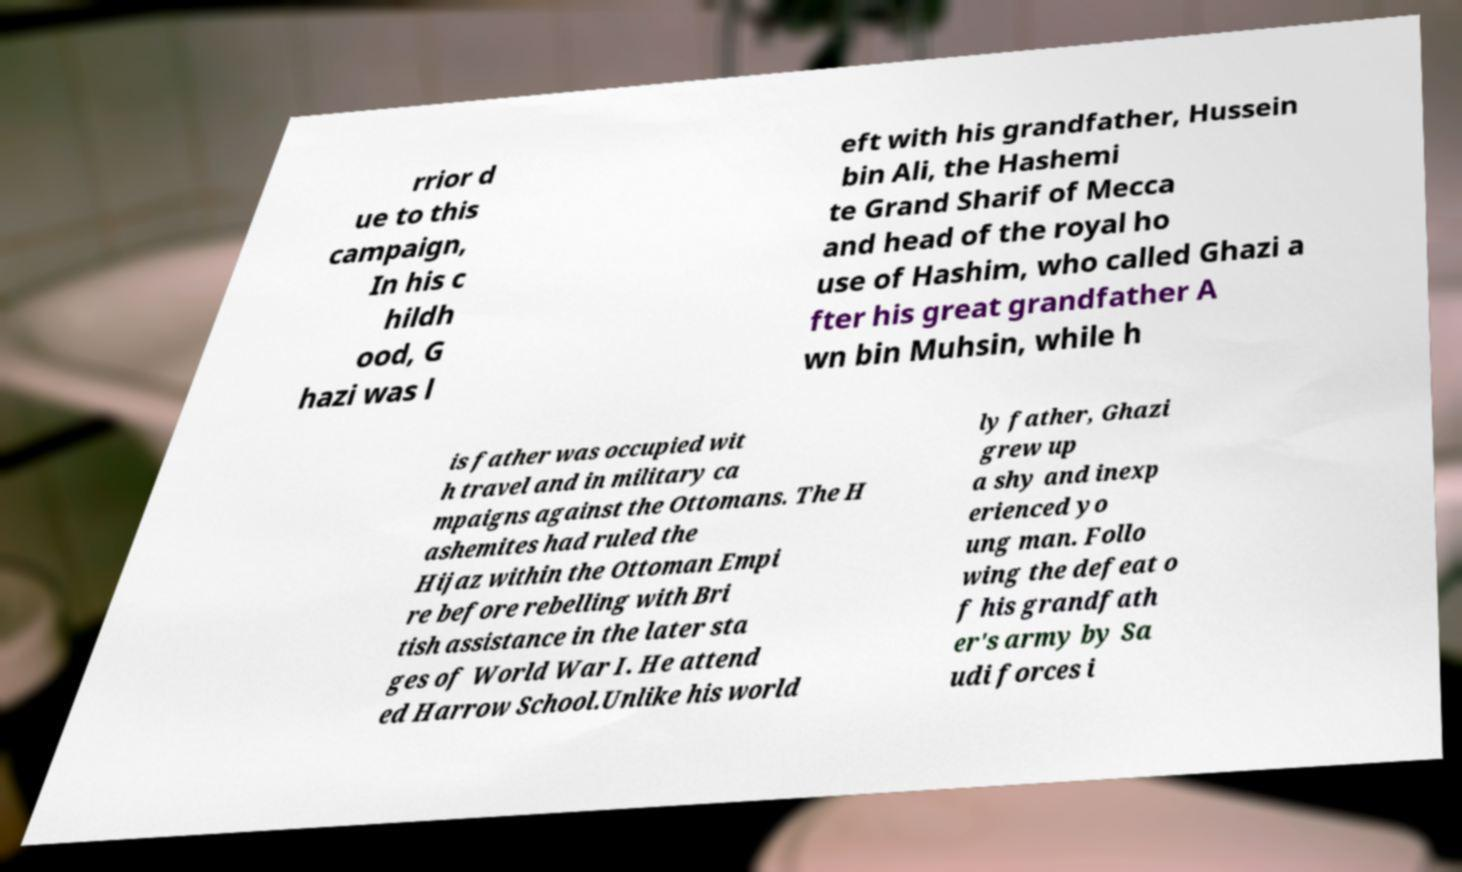There's text embedded in this image that I need extracted. Can you transcribe it verbatim? rrior d ue to this campaign, In his c hildh ood, G hazi was l eft with his grandfather, Hussein bin Ali, the Hashemi te Grand Sharif of Mecca and head of the royal ho use of Hashim, who called Ghazi a fter his great grandfather A wn bin Muhsin, while h is father was occupied wit h travel and in military ca mpaigns against the Ottomans. The H ashemites had ruled the Hijaz within the Ottoman Empi re before rebelling with Bri tish assistance in the later sta ges of World War I. He attend ed Harrow School.Unlike his world ly father, Ghazi grew up a shy and inexp erienced yo ung man. Follo wing the defeat o f his grandfath er's army by Sa udi forces i 